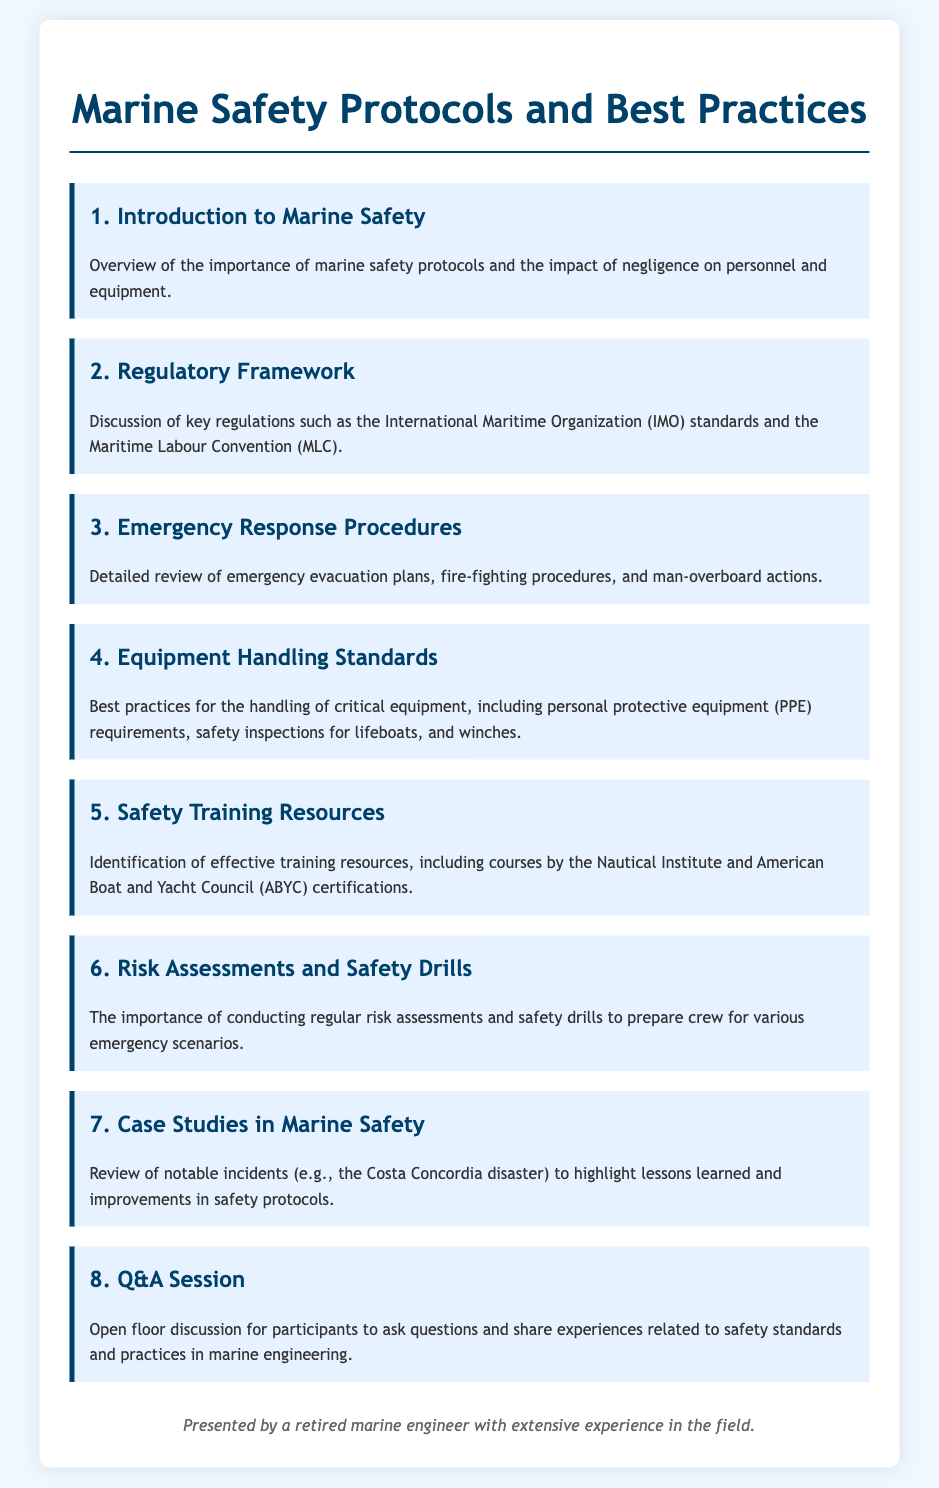What is the first agenda item? The first agenda item is titled "Introduction to Marine Safety."
Answer: Introduction to Marine Safety Which organization’s standards are discussed in the regulatory framework? The agenda mentions the International Maritime Organization (IMO).
Answer: International Maritime Organization (IMO) What emergency situation is addressed in the third agenda item? The third agenda item focuses on emergency evacuation plans.
Answer: Emergency evacuation plans What personal protective equipment is required in the equipment handling standards? The agenda specifies personal protective equipment (PPE) requirements.
Answer: personal protective equipment (PPE) How many case studies in marine safety are reviewed? The document indicates that one notable incident is reviewed, specifically the Costa Concordia disaster.
Answer: One What does the last agenda item entail? The last agenda item is an open floor discussion for questions and sharing experiences.
Answer: Open floor discussion What training resource is identified in the safety training resources? The Nautical Institute is mentioned as an effective training resource.
Answer: Nautical Institute What is emphasized in the sixth agenda item? The sixth agenda item emphasizes the importance of conducting regular risk assessments and safety drills.
Answer: Regular risk assessments and safety drills 